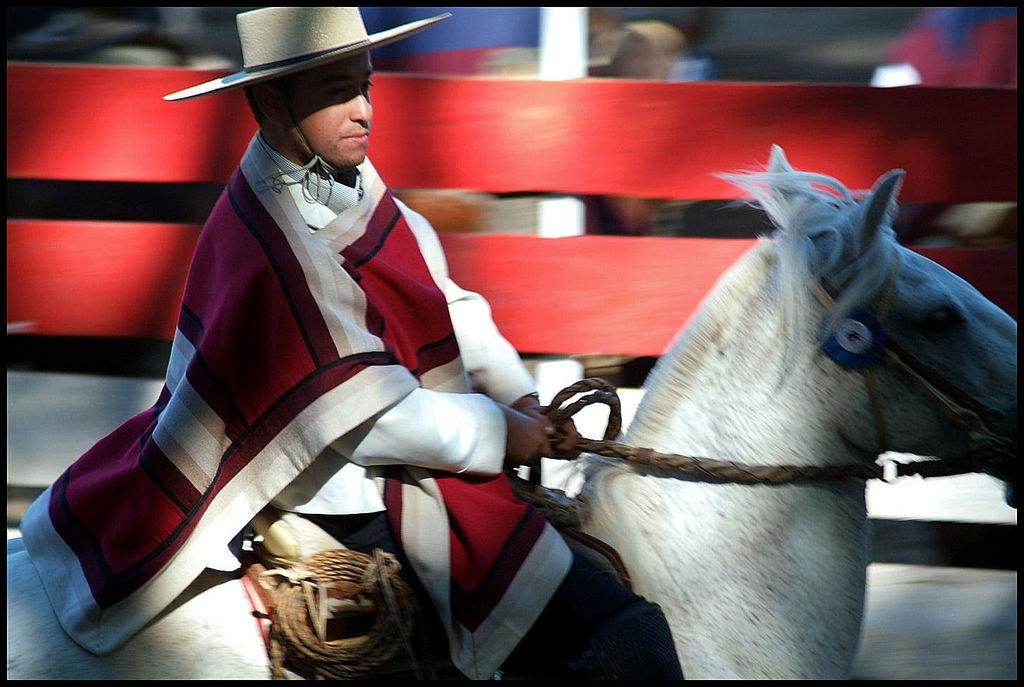Who is the main subject in the image? There is a man in the image. What is the man doing in the image? The man is sitting on a horse. What type of straw is the man using to build a church in the image? There is no straw or church present in the image; it features a man sitting on a horse. Does the existence of the man in the image prove the existence of a higher power? The image does not provide any information about the existence of a higher power, as it only shows a man sitting on a horse. 